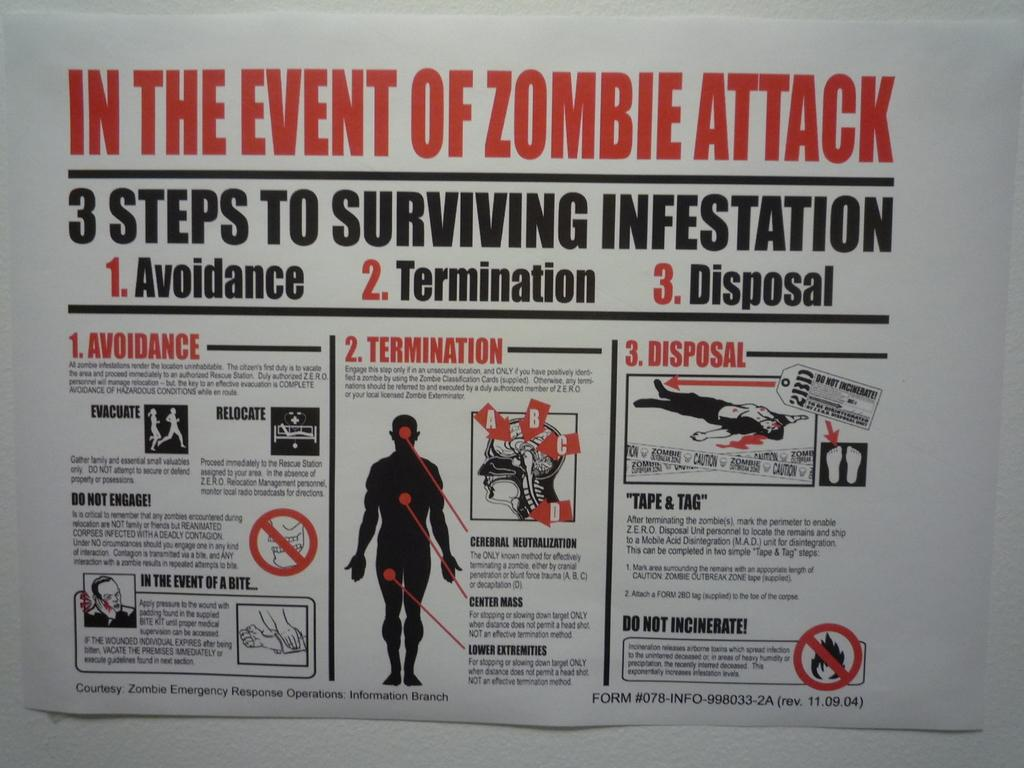<image>
Provide a brief description of the given image. A poster gives detailed on instructions on what to do " In the event of a zombie attack" 